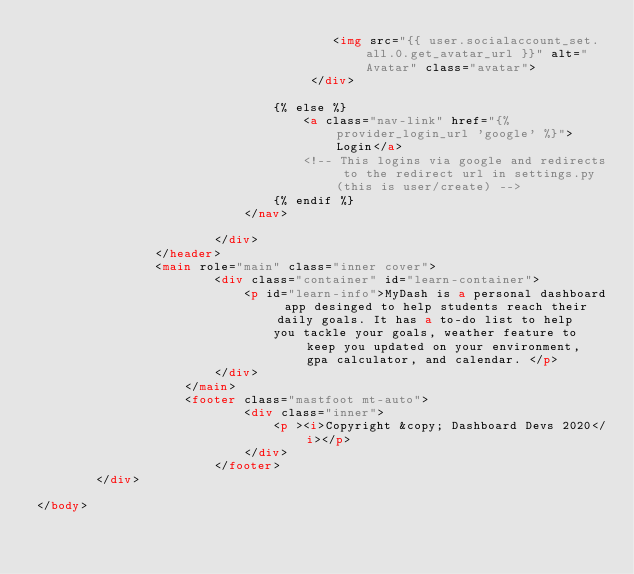<code> <loc_0><loc_0><loc_500><loc_500><_HTML_>                                        <img src="{{ user.socialaccount_set.all.0.get_avatar_url }}" alt="Avatar" class="avatar">
                                     </div>
            
                                {% else %}
                                    <a class="nav-link" href="{% provider_login_url 'google' %}">Login</a>
                                    <!-- This logins via google and redirects to the redirect url in settings.py (this is user/create) -->
                                {% endif %}
                            </nav>
        
                        </div>
                </header>
                <main role="main" class="inner cover">
                        <div class="container" id="learn-container">
                            <p id="learn-info">MyDash is a personal dashboard app desinged to help students reach their daily goals. It has a to-do list to help
                                you tackle your goals, weather feature to keep you updated on your environment, gpa calculator, and calendar. </p>
                        </div>
                    </main>
                    <footer class="mastfoot mt-auto">
                            <div class="inner">
                                <p ><i>Copyright &copy; Dashboard Devs 2020</i></p>
                            </div>
                        </footer>
        </div>

</body></code> 